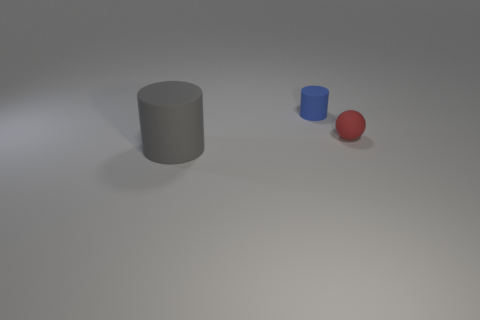Imagine I wanted to use the blue cylinder to roll over the red sphere, would its size allow for this? Given the relative sizes of the blue cylinder and the red sphere, the cylinder being taller and apparently wider, it would be physically capable of rolling over the sphere if set in motion correctly. 